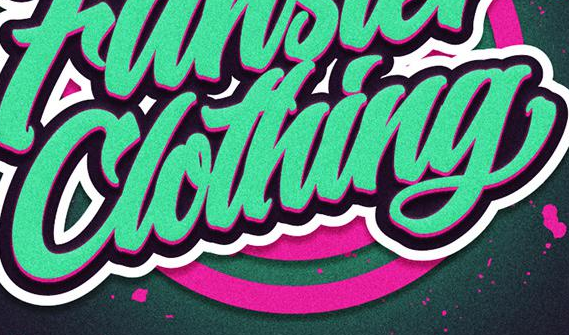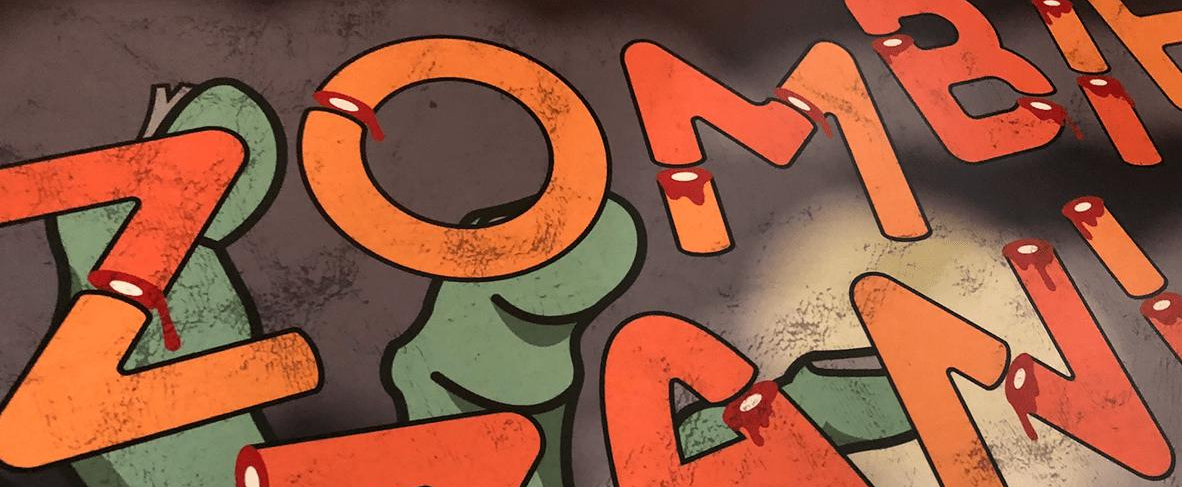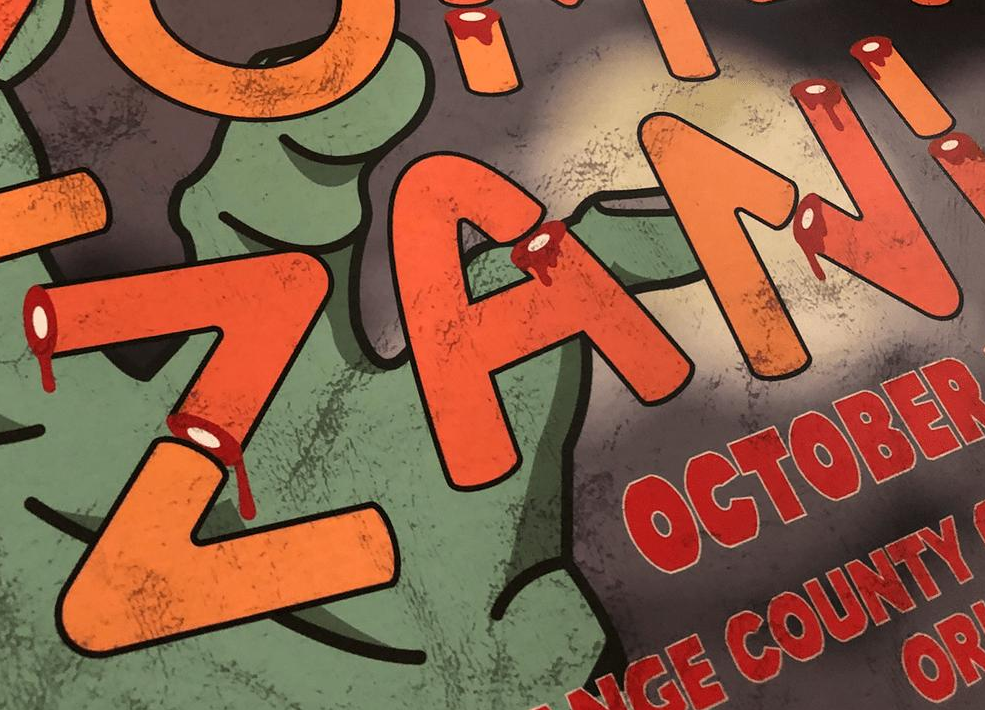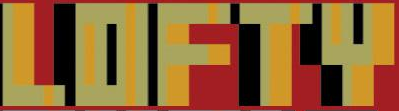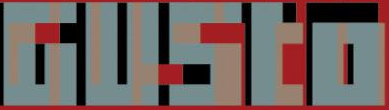Transcribe the words shown in these images in order, separated by a semicolon. Clothing; ZOMBI; ZANI; LOFTY; GUSto 